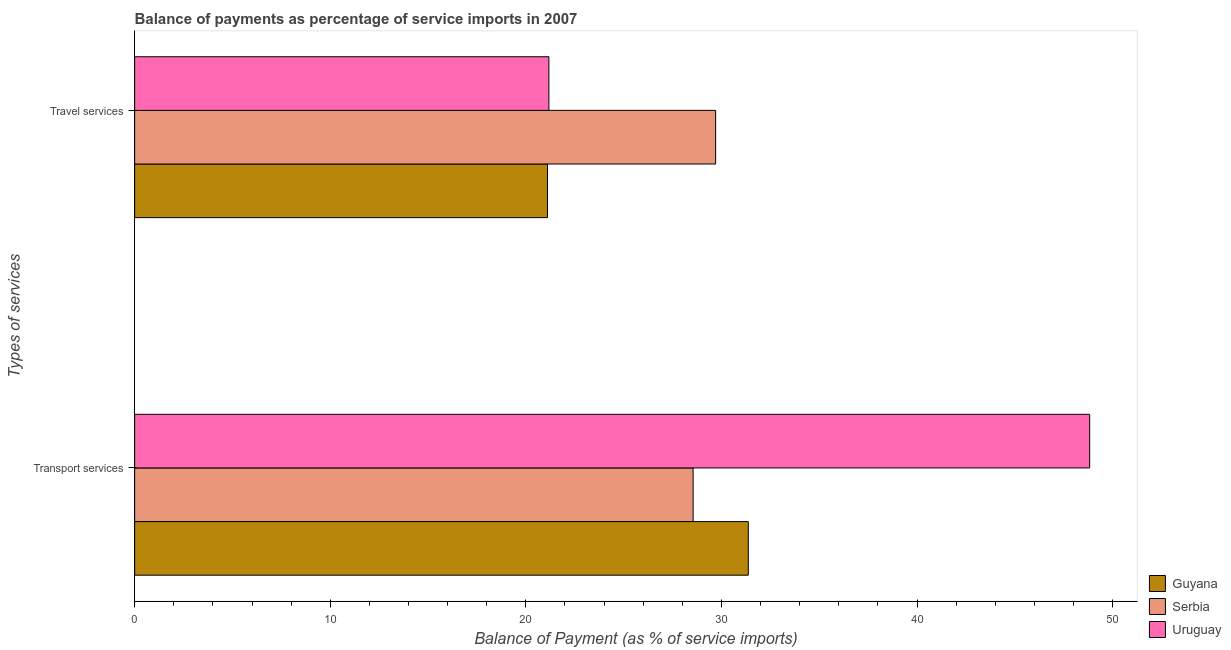How many different coloured bars are there?
Make the answer very short. 3. Are the number of bars per tick equal to the number of legend labels?
Offer a very short reply. Yes. Are the number of bars on each tick of the Y-axis equal?
Make the answer very short. Yes. What is the label of the 1st group of bars from the top?
Ensure brevity in your answer.  Travel services. What is the balance of payments of travel services in Uruguay?
Make the answer very short. 21.18. Across all countries, what is the maximum balance of payments of transport services?
Offer a terse response. 48.82. Across all countries, what is the minimum balance of payments of travel services?
Offer a very short reply. 21.11. In which country was the balance of payments of travel services maximum?
Offer a terse response. Serbia. In which country was the balance of payments of travel services minimum?
Provide a succinct answer. Guyana. What is the total balance of payments of travel services in the graph?
Offer a terse response. 71.99. What is the difference between the balance of payments of travel services in Guyana and that in Uruguay?
Your answer should be very brief. -0.07. What is the difference between the balance of payments of travel services in Guyana and the balance of payments of transport services in Serbia?
Your answer should be compact. -7.44. What is the average balance of payments of travel services per country?
Your response must be concise. 24. What is the difference between the balance of payments of travel services and balance of payments of transport services in Guyana?
Provide a succinct answer. -10.26. In how many countries, is the balance of payments of transport services greater than 38 %?
Make the answer very short. 1. What is the ratio of the balance of payments of travel services in Uruguay to that in Serbia?
Make the answer very short. 0.71. Is the balance of payments of travel services in Guyana less than that in Uruguay?
Give a very brief answer. Yes. In how many countries, is the balance of payments of travel services greater than the average balance of payments of travel services taken over all countries?
Offer a very short reply. 1. What does the 1st bar from the top in Transport services represents?
Provide a succinct answer. Uruguay. What does the 2nd bar from the bottom in Transport services represents?
Offer a very short reply. Serbia. Are all the bars in the graph horizontal?
Make the answer very short. Yes. How many countries are there in the graph?
Your answer should be very brief. 3. Does the graph contain grids?
Keep it short and to the point. No. Where does the legend appear in the graph?
Offer a very short reply. Bottom right. How many legend labels are there?
Make the answer very short. 3. How are the legend labels stacked?
Offer a very short reply. Vertical. What is the title of the graph?
Give a very brief answer. Balance of payments as percentage of service imports in 2007. Does "Sri Lanka" appear as one of the legend labels in the graph?
Provide a succinct answer. No. What is the label or title of the X-axis?
Your answer should be compact. Balance of Payment (as % of service imports). What is the label or title of the Y-axis?
Offer a terse response. Types of services. What is the Balance of Payment (as % of service imports) in Guyana in Transport services?
Provide a succinct answer. 31.37. What is the Balance of Payment (as % of service imports) of Serbia in Transport services?
Provide a short and direct response. 28.55. What is the Balance of Payment (as % of service imports) in Uruguay in Transport services?
Offer a very short reply. 48.82. What is the Balance of Payment (as % of service imports) in Guyana in Travel services?
Offer a terse response. 21.11. What is the Balance of Payment (as % of service imports) of Serbia in Travel services?
Offer a terse response. 29.7. What is the Balance of Payment (as % of service imports) in Uruguay in Travel services?
Offer a terse response. 21.18. Across all Types of services, what is the maximum Balance of Payment (as % of service imports) of Guyana?
Ensure brevity in your answer.  31.37. Across all Types of services, what is the maximum Balance of Payment (as % of service imports) in Serbia?
Your answer should be compact. 29.7. Across all Types of services, what is the maximum Balance of Payment (as % of service imports) in Uruguay?
Offer a very short reply. 48.82. Across all Types of services, what is the minimum Balance of Payment (as % of service imports) of Guyana?
Keep it short and to the point. 21.11. Across all Types of services, what is the minimum Balance of Payment (as % of service imports) of Serbia?
Your response must be concise. 28.55. Across all Types of services, what is the minimum Balance of Payment (as % of service imports) in Uruguay?
Ensure brevity in your answer.  21.18. What is the total Balance of Payment (as % of service imports) in Guyana in the graph?
Keep it short and to the point. 52.48. What is the total Balance of Payment (as % of service imports) in Serbia in the graph?
Offer a very short reply. 58.25. What is the total Balance of Payment (as % of service imports) of Uruguay in the graph?
Provide a succinct answer. 70. What is the difference between the Balance of Payment (as % of service imports) of Guyana in Transport services and that in Travel services?
Make the answer very short. 10.26. What is the difference between the Balance of Payment (as % of service imports) in Serbia in Transport services and that in Travel services?
Provide a short and direct response. -1.15. What is the difference between the Balance of Payment (as % of service imports) of Uruguay in Transport services and that in Travel services?
Your response must be concise. 27.65. What is the difference between the Balance of Payment (as % of service imports) of Guyana in Transport services and the Balance of Payment (as % of service imports) of Serbia in Travel services?
Your answer should be compact. 1.67. What is the difference between the Balance of Payment (as % of service imports) in Guyana in Transport services and the Balance of Payment (as % of service imports) in Uruguay in Travel services?
Your response must be concise. 10.19. What is the difference between the Balance of Payment (as % of service imports) of Serbia in Transport services and the Balance of Payment (as % of service imports) of Uruguay in Travel services?
Offer a terse response. 7.37. What is the average Balance of Payment (as % of service imports) in Guyana per Types of services?
Your answer should be compact. 26.24. What is the average Balance of Payment (as % of service imports) in Serbia per Types of services?
Make the answer very short. 29.13. What is the average Balance of Payment (as % of service imports) of Uruguay per Types of services?
Make the answer very short. 35. What is the difference between the Balance of Payment (as % of service imports) of Guyana and Balance of Payment (as % of service imports) of Serbia in Transport services?
Your answer should be very brief. 2.82. What is the difference between the Balance of Payment (as % of service imports) in Guyana and Balance of Payment (as % of service imports) in Uruguay in Transport services?
Provide a succinct answer. -17.45. What is the difference between the Balance of Payment (as % of service imports) in Serbia and Balance of Payment (as % of service imports) in Uruguay in Transport services?
Ensure brevity in your answer.  -20.27. What is the difference between the Balance of Payment (as % of service imports) of Guyana and Balance of Payment (as % of service imports) of Serbia in Travel services?
Make the answer very short. -8.59. What is the difference between the Balance of Payment (as % of service imports) of Guyana and Balance of Payment (as % of service imports) of Uruguay in Travel services?
Keep it short and to the point. -0.07. What is the difference between the Balance of Payment (as % of service imports) of Serbia and Balance of Payment (as % of service imports) of Uruguay in Travel services?
Your answer should be very brief. 8.52. What is the ratio of the Balance of Payment (as % of service imports) of Guyana in Transport services to that in Travel services?
Your answer should be very brief. 1.49. What is the ratio of the Balance of Payment (as % of service imports) of Serbia in Transport services to that in Travel services?
Ensure brevity in your answer.  0.96. What is the ratio of the Balance of Payment (as % of service imports) in Uruguay in Transport services to that in Travel services?
Provide a short and direct response. 2.31. What is the difference between the highest and the second highest Balance of Payment (as % of service imports) in Guyana?
Give a very brief answer. 10.26. What is the difference between the highest and the second highest Balance of Payment (as % of service imports) of Serbia?
Your answer should be very brief. 1.15. What is the difference between the highest and the second highest Balance of Payment (as % of service imports) of Uruguay?
Give a very brief answer. 27.65. What is the difference between the highest and the lowest Balance of Payment (as % of service imports) of Guyana?
Offer a terse response. 10.26. What is the difference between the highest and the lowest Balance of Payment (as % of service imports) of Serbia?
Make the answer very short. 1.15. What is the difference between the highest and the lowest Balance of Payment (as % of service imports) in Uruguay?
Provide a short and direct response. 27.65. 